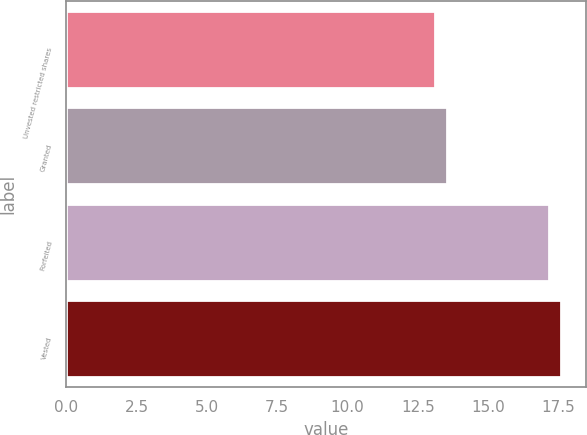Convert chart. <chart><loc_0><loc_0><loc_500><loc_500><bar_chart><fcel>Unvested restricted shares<fcel>Granted<fcel>Forfeited<fcel>Vested<nl><fcel>13.12<fcel>13.52<fcel>17.18<fcel>17.59<nl></chart> 